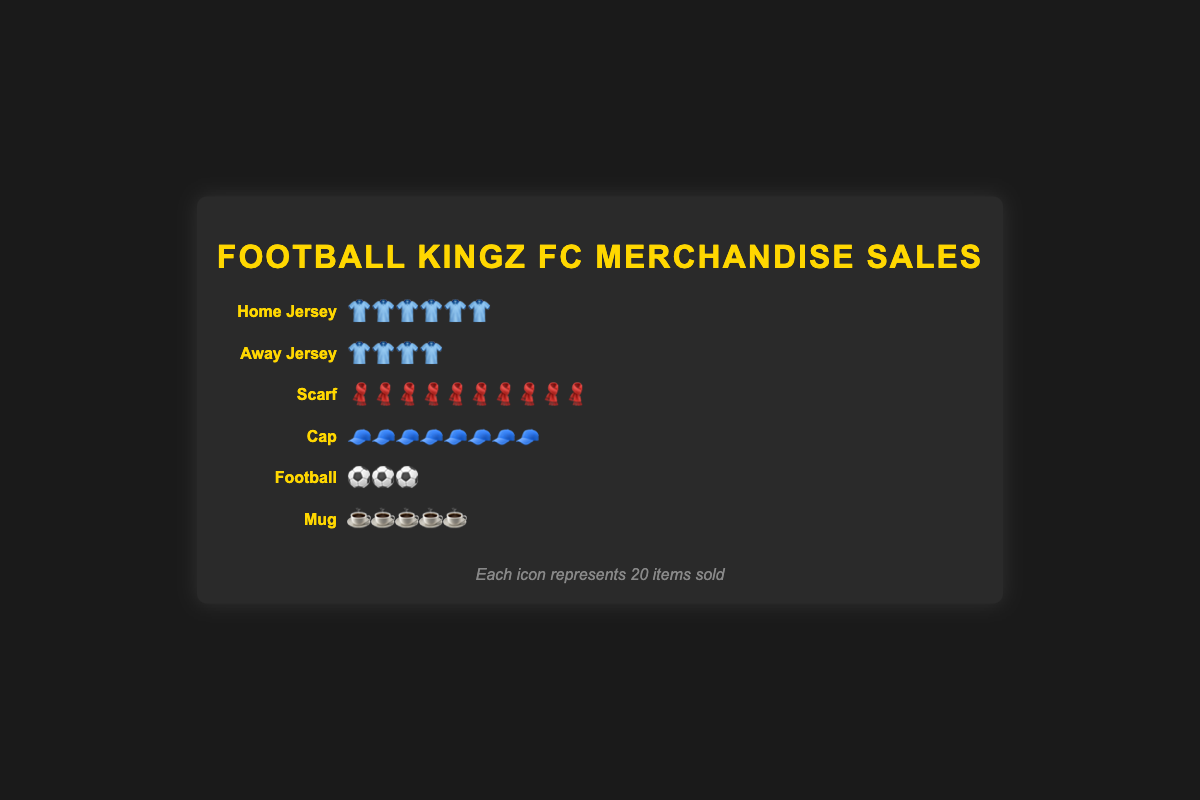What's the most sold merchandise type? The figure shows that the "Scarf" has the most icons representing sales (each icon represents 20 items), indicating it has the highest sales.
Answer: Scarf What's the total number of products sold? Summing up all sales: Home Jersey (1200) + Away Jersey (800) + Scarf (2000) + Cap (1500) + Football (500) + Mug (1000) = 7000.
Answer: 7000 Which product has the least sales? The figure's sales representation shows "Football" has the fewest icons, signifying the least sales.
Answer: Football How many more scarves were sold compared to caps? Scarves sold: 2000, Caps sold: 1500. Difference = 2000 - 1500 = 500.
Answer: 500 What percentage of the total sales do mugs represent? Total sales: 7000, Mug sales: 1000. Percentage = (1000 / 7000) * 100 ≈ 14.29%.
Answer: 14.29% If each icon represents 20 items, how many icons should be there for home jerseys? Home Jersey sales: 1200. Number of icons: 1200 / 20 = 60.
Answer: 60 Compare the sales of home jerseys and away jerseys. Home jerseys: 1200, Away jerseys: 800. Home jerseys sold more than away jerseys by 1200 - 800 = 400.
Answer: Home jerseys sold 400 more Which two product types have combined sales equal to the total sales of scarves? Scarf sales: 2000. Combined sales of Cap (1500) and Football (500) = 2000, which matches the total sales of scarves.
Answer: Cap and Football How much more are the total sales of wearable items (jerseys, scarves, caps) compared to non-wearable items (football, mugs)? Wearable: Home Jersey (1200) + Away Jersey (800) + Scarf (2000) + Cap (1500) = 5500, Non-wearable: Football (500) + Mug (1000) = 1500. Difference = 5500 - 1500 = 4000.
Answer: 4000 Which merchandise type is in the middle when sorted by sales in ascending order? Sorted sales: Football (500), Away Jersey (800), Mug (1000), Home Jersey (1200), Cap (1500), Scarf (2000). The middle type is Mug.
Answer: Mug 